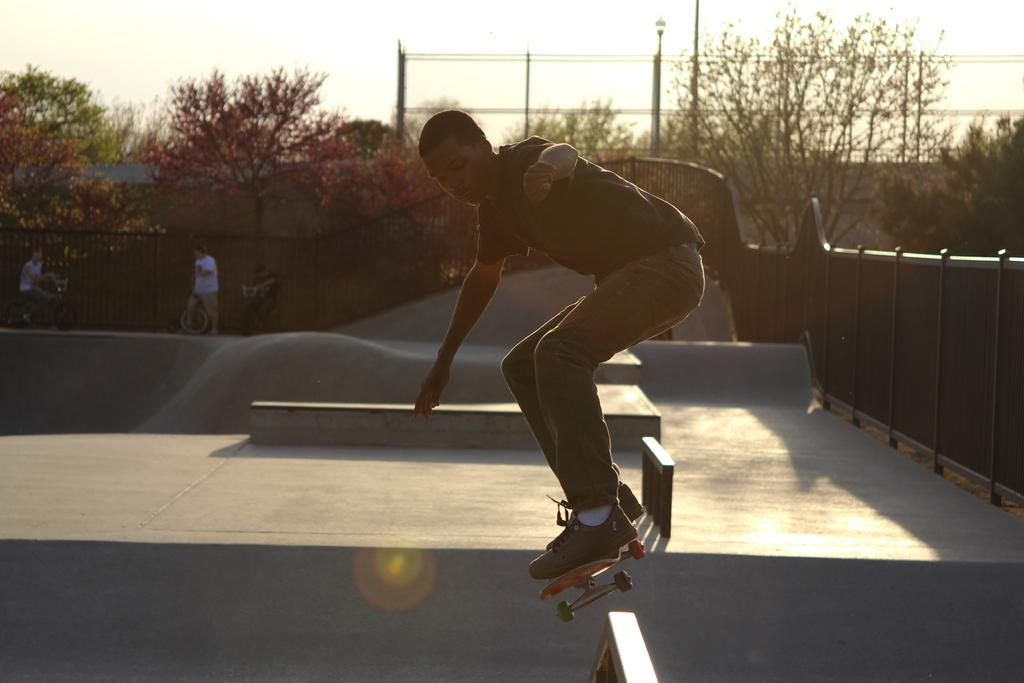What is the man in the image doing? The man is skating in the image. What is the man using to skate? The man is on a skateboard. Where is the skating taking place? The skating is taking place in a skating park. What can be seen in the background of the image? There are trees and the sky visible in the background of the image. What is on the right side of the image? There is a wall on the right side of the image. What type of grain is being harvested in the image? There is no grain being harvested in the image; it features a man skating on a skateboard in a skating park. What type of boot is the man wearing in the image? The image does not show the man's footwear, so it cannot be determined what type of boot he might be wearing. 